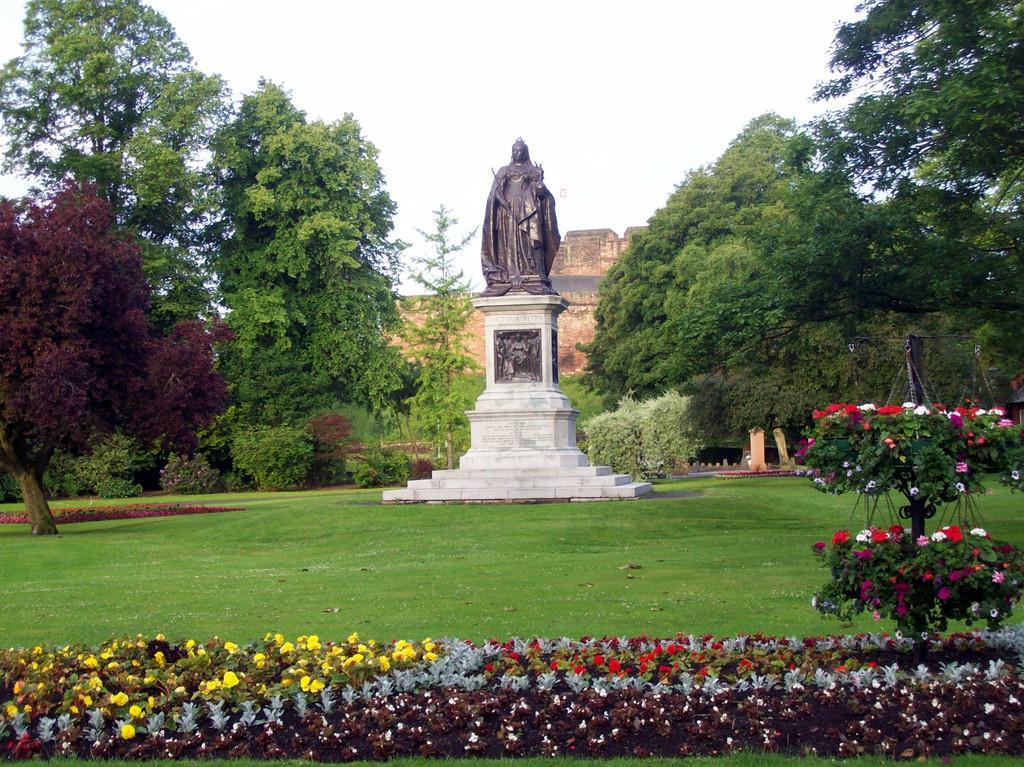How would you summarize this image in a sentence or two? In this image I can see the statue of the person. To the side of the statue I can see many trees. In-front of the statue I can see the flowers which are in pink, red, white, yellow and ash color. In the background I can see the wall and the sky. 